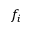<formula> <loc_0><loc_0><loc_500><loc_500>f _ { i }</formula> 